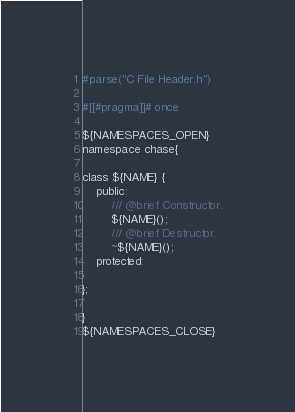Convert code to text. <code><loc_0><loc_0><loc_500><loc_500><_C_>#parse("C File Header.h")

#[[#pragma]]# once

${NAMESPACES_OPEN}
namespace chase{

class ${NAME} {
    public:
        /// @brief Constructor.
        ${NAME}();
        /// @brief Destructor.
        ~${NAME}();
    protected:
        
};

}
${NAMESPACES_CLOSE}</code> 